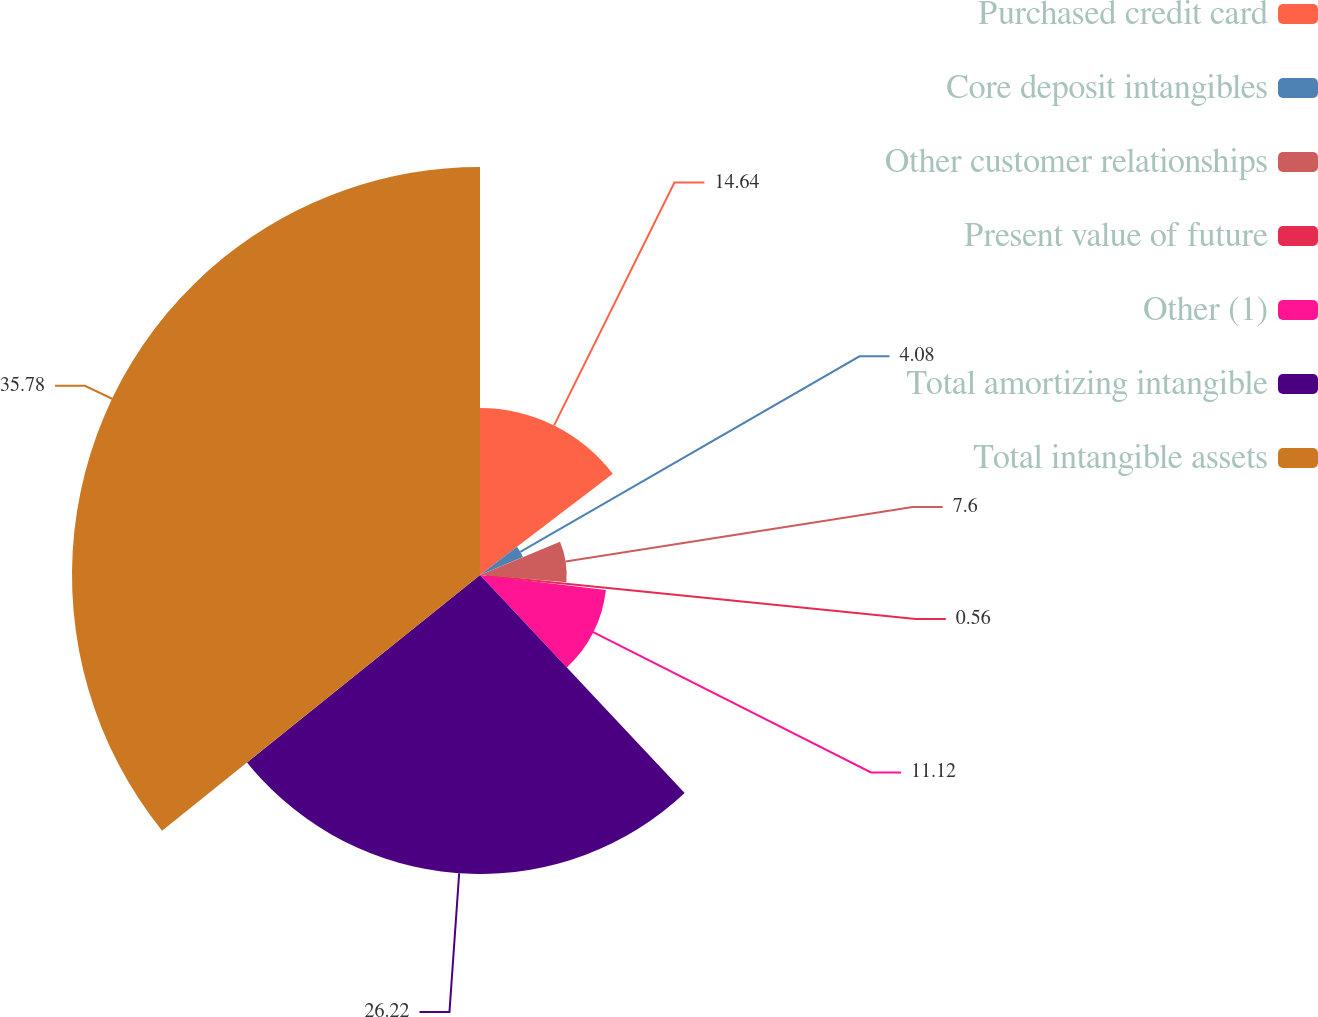Convert chart to OTSL. <chart><loc_0><loc_0><loc_500><loc_500><pie_chart><fcel>Purchased credit card<fcel>Core deposit intangibles<fcel>Other customer relationships<fcel>Present value of future<fcel>Other (1)<fcel>Total amortizing intangible<fcel>Total intangible assets<nl><fcel>14.64%<fcel>4.08%<fcel>7.6%<fcel>0.56%<fcel>11.12%<fcel>26.22%<fcel>35.78%<nl></chart> 